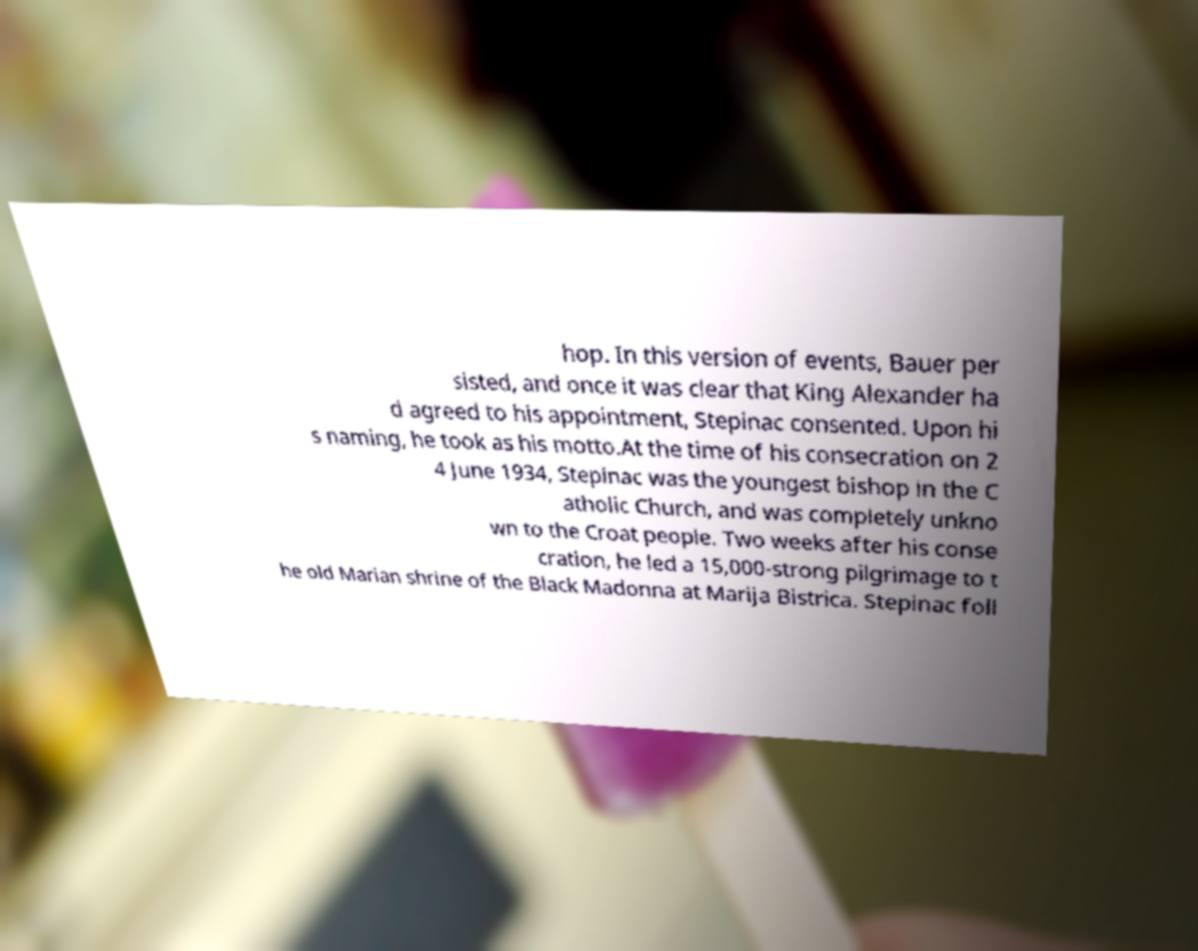Please read and relay the text visible in this image. What does it say? hop. In this version of events, Bauer per sisted, and once it was clear that King Alexander ha d agreed to his appointment, Stepinac consented. Upon hi s naming, he took as his motto.At the time of his consecration on 2 4 June 1934, Stepinac was the youngest bishop in the C atholic Church, and was completely unkno wn to the Croat people. Two weeks after his conse cration, he led a 15,000-strong pilgrimage to t he old Marian shrine of the Black Madonna at Marija Bistrica. Stepinac foll 